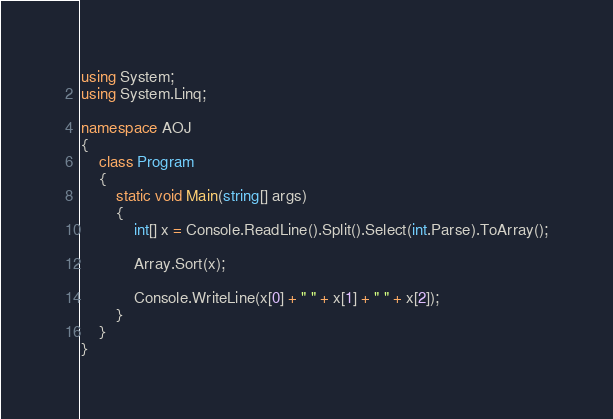Convert code to text. <code><loc_0><loc_0><loc_500><loc_500><_C#_>using System;
using System.Linq;

namespace AOJ
{
    class Program
    {
        static void Main(string[] args)
        {
            int[] x = Console.ReadLine().Split().Select(int.Parse).ToArray();

            Array.Sort(x);

            Console.WriteLine(x[0] + " " + x[1] + " " + x[2]);
        }
    }
}

</code> 